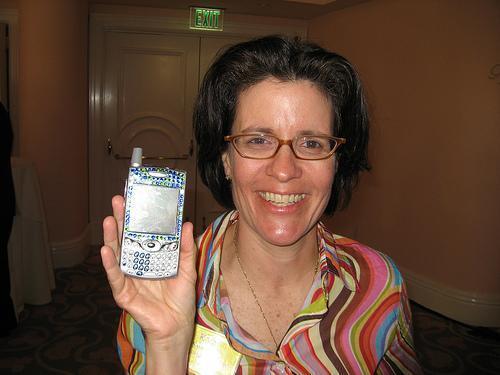How many cell phones is the woman holding?
Give a very brief answer. 1. 